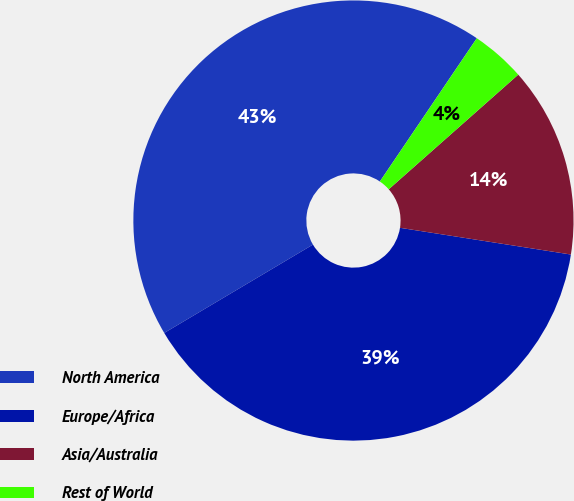Convert chart to OTSL. <chart><loc_0><loc_0><loc_500><loc_500><pie_chart><fcel>North America<fcel>Europe/Africa<fcel>Asia/Australia<fcel>Rest of World<nl><fcel>43.0%<fcel>39.0%<fcel>14.0%<fcel>4.0%<nl></chart> 